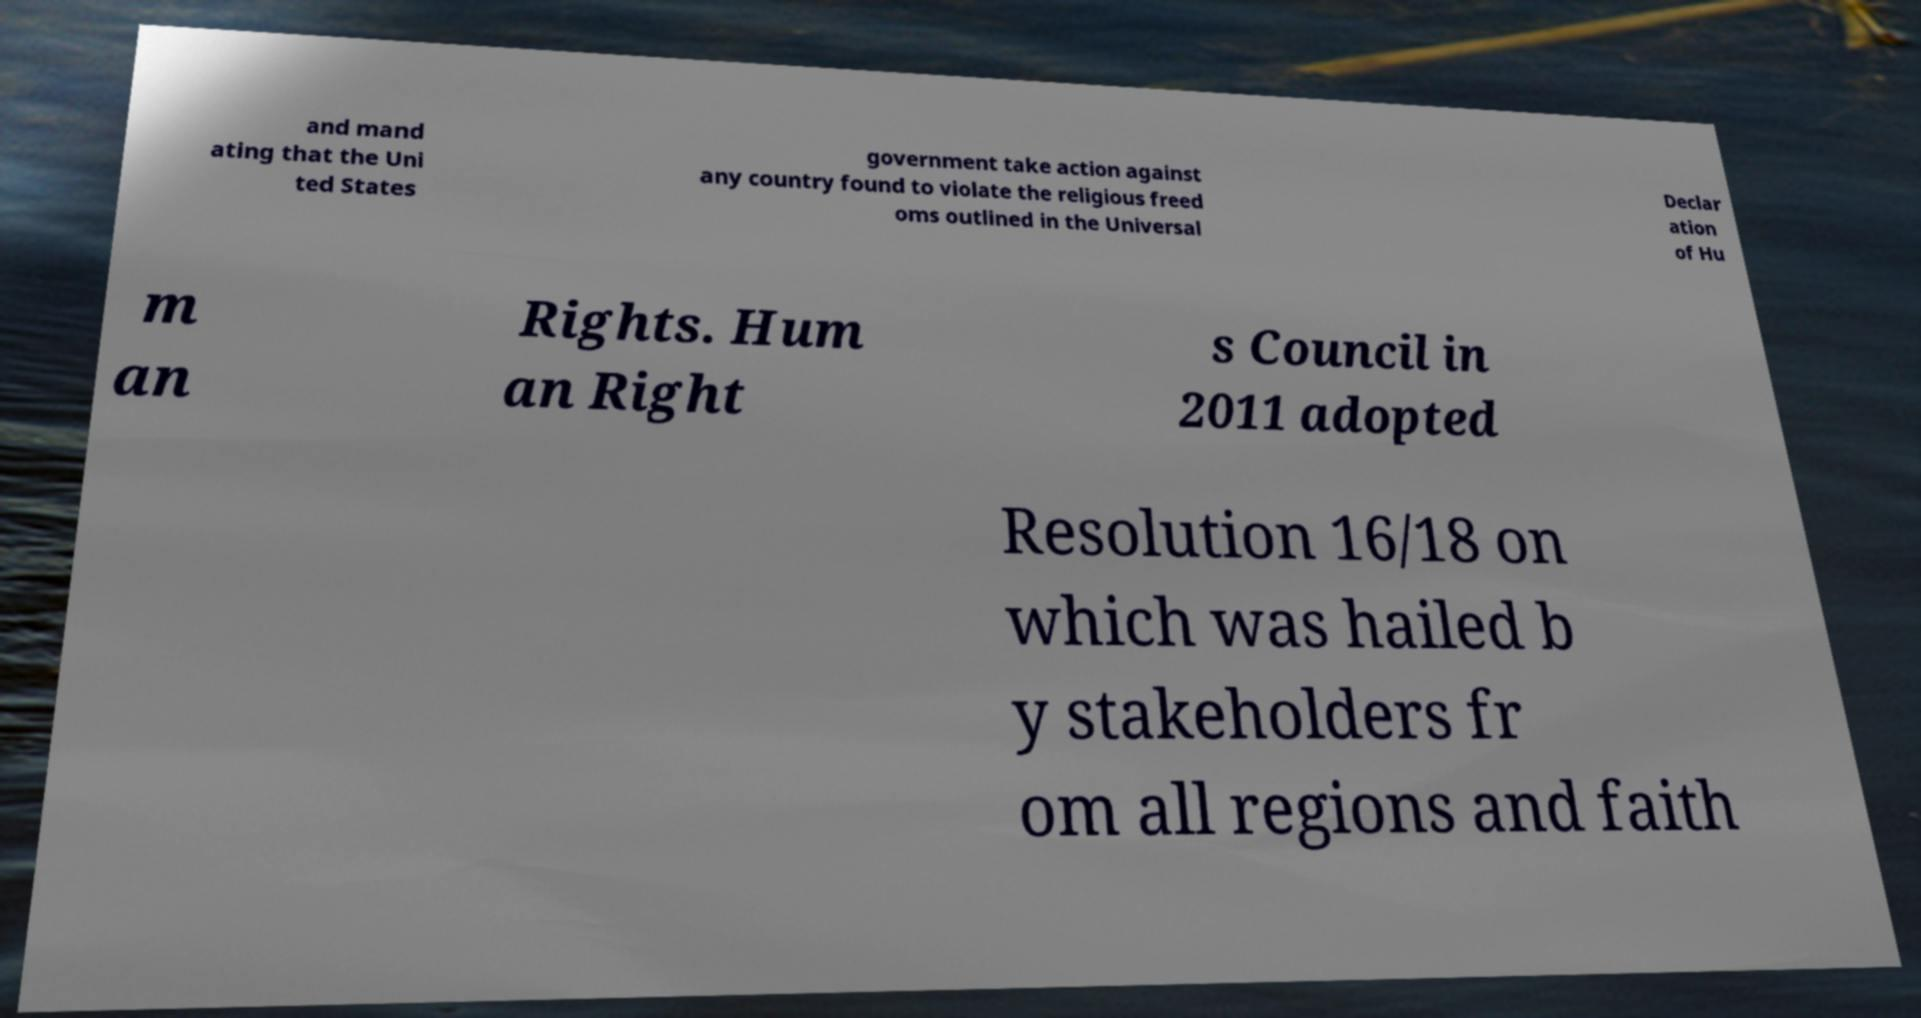I need the written content from this picture converted into text. Can you do that? and mand ating that the Uni ted States government take action against any country found to violate the religious freed oms outlined in the Universal Declar ation of Hu m an Rights. Hum an Right s Council in 2011 adopted Resolution 16/18 on which was hailed b y stakeholders fr om all regions and faith 